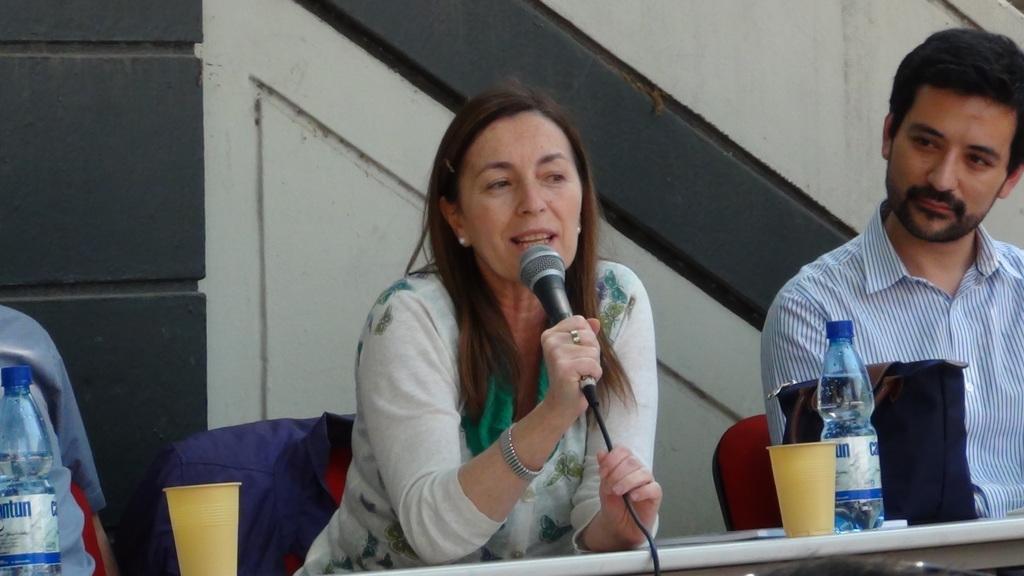Describe this image in one or two sentences. In this image I see a woman and a man and both of them are sitting on the chairs, I can also see that this woman is holding the mic and in front of them I see the bottles, bag and the cups. 